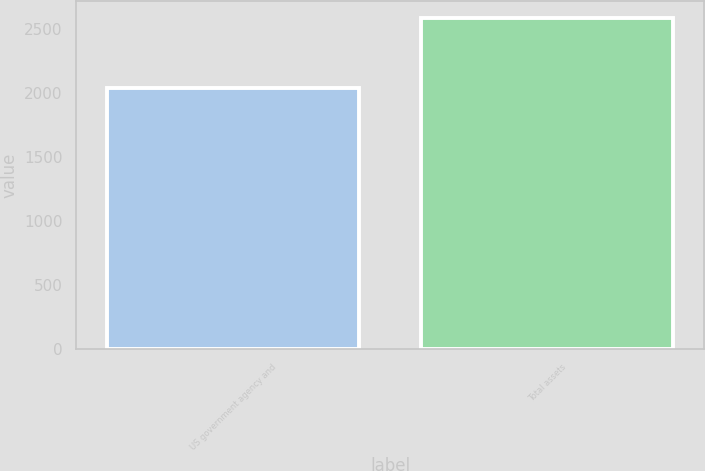<chart> <loc_0><loc_0><loc_500><loc_500><bar_chart><fcel>US government agency and<fcel>Total assets<nl><fcel>2042<fcel>2589<nl></chart> 